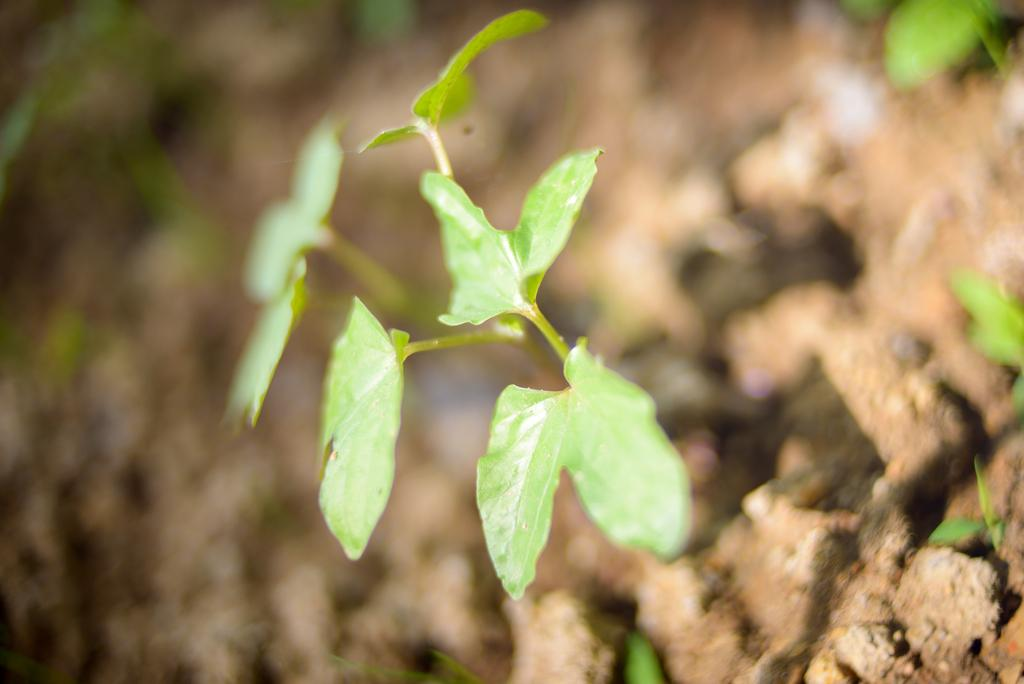What color are the leaves in the image? The leaves in the image are green. Can you describe the overall clarity of the image? The image appears to be slightly blurry. What thought is expressed by the leaves in the image? The leaves in the image do not express any thoughts, as they are inanimate objects. 